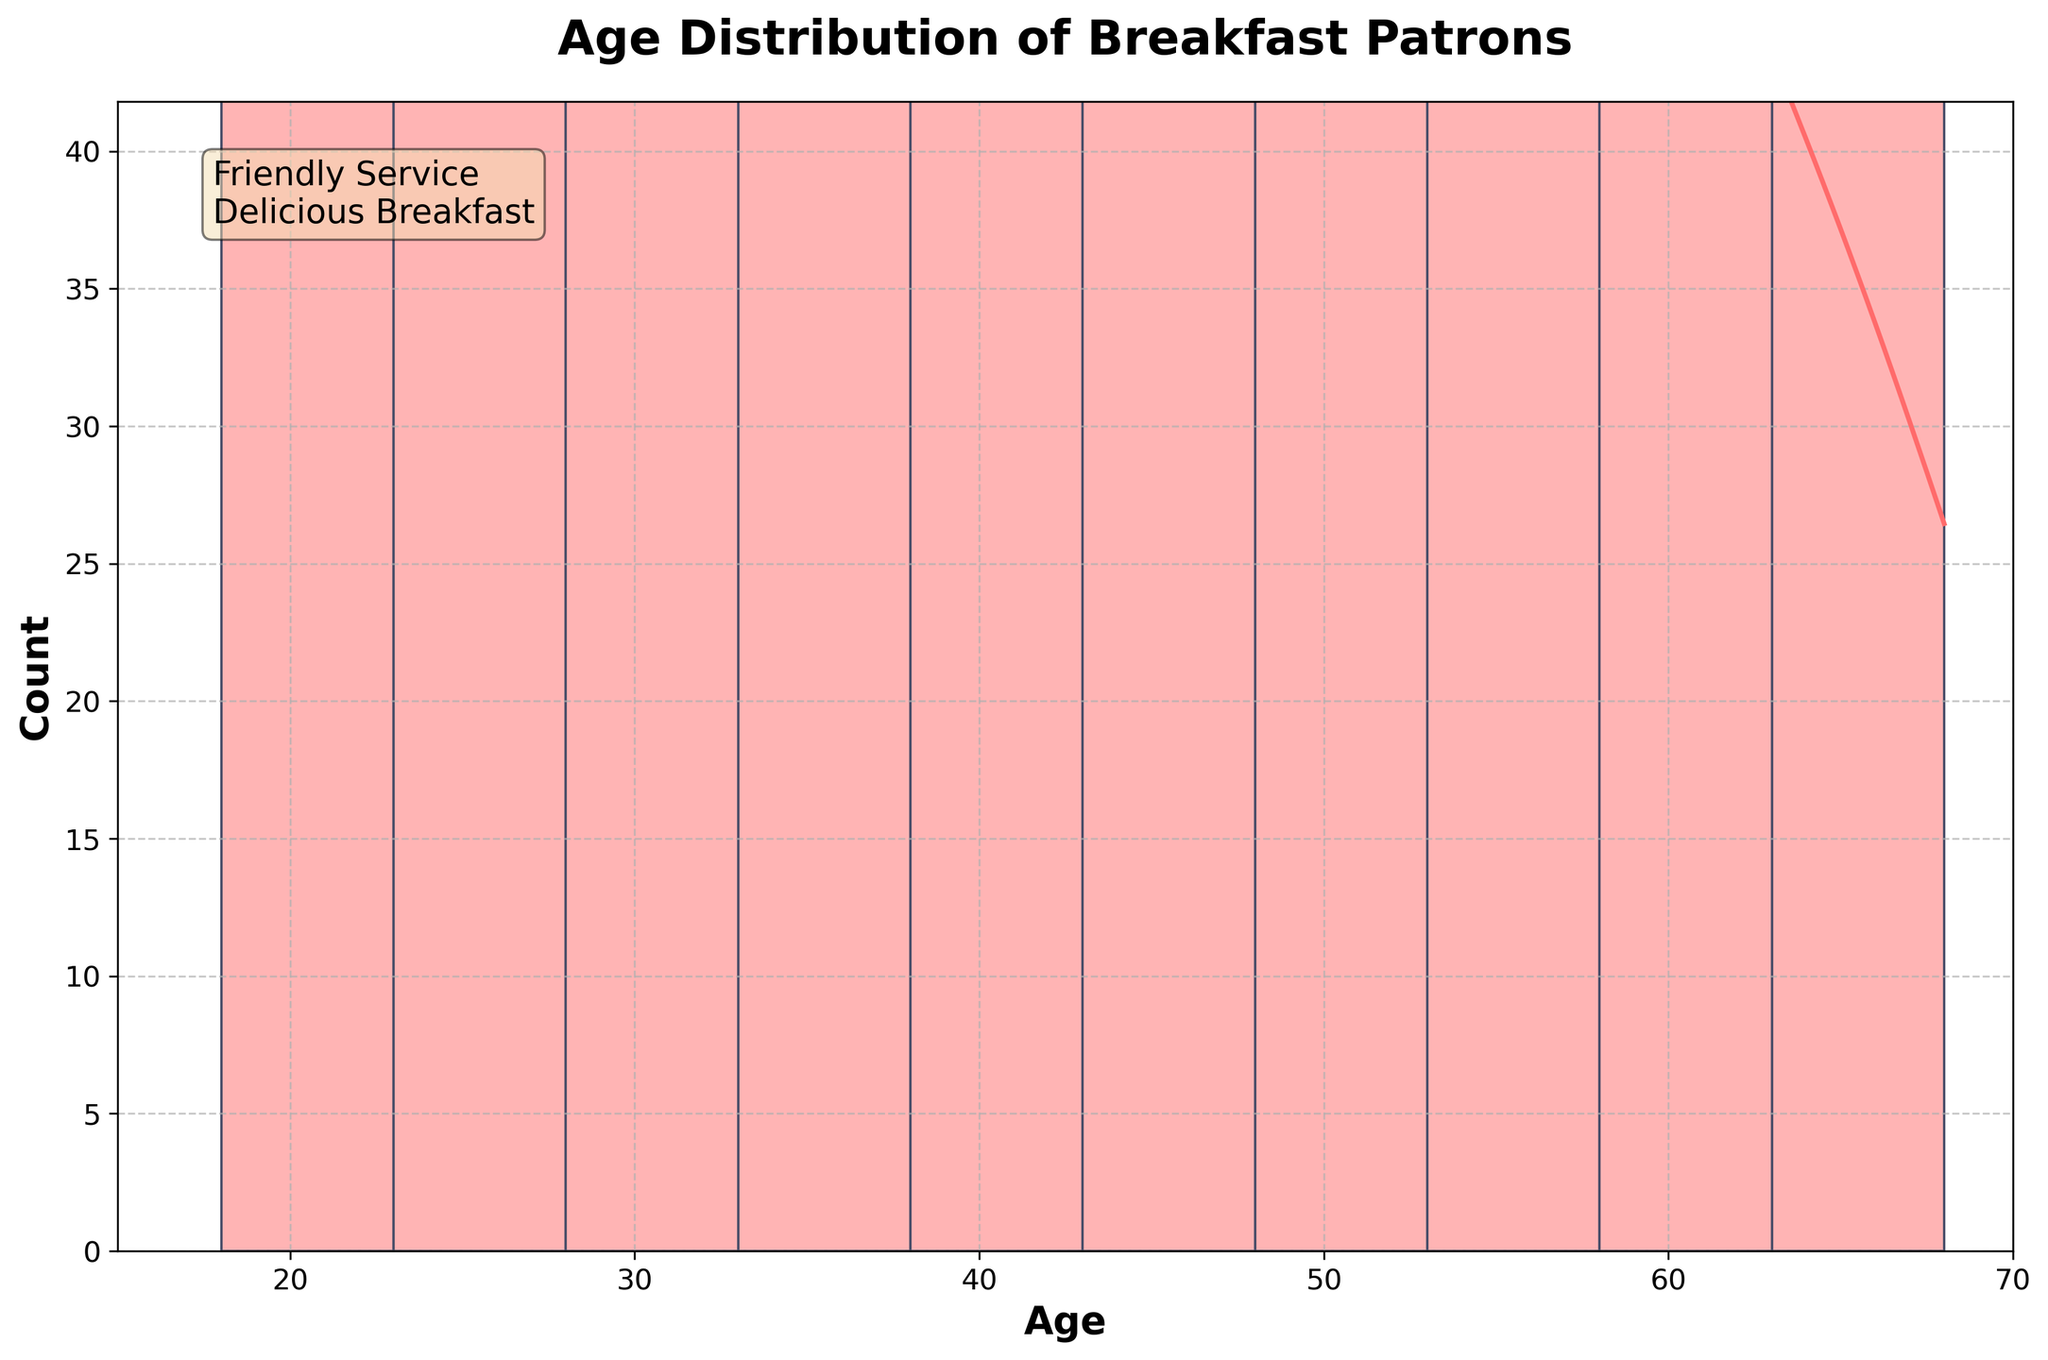what is the title of the figure? The title is usually located at the top center of the figure. It summarizes what the figure is about. In this case, it states, "Age Distribution of Breakfast Patrons."
Answer: Age Distribution of Breakfast Patrons what is the color of the density curve in the figure? The density curve is represented by a line in the figure. It is visually distinct from the bars due to its unique color. In this case, it is a greenish color.
Answer: Greenish How many age groups are there in the histogram? The age groups on the x-axis are distinct bars separated into different age ranges. By counting the distinct separations along the x-axis, we determine the number of age groups.
Answer: 14 what is the age range with the highest count of breakfast patrons? Looking at the bars, we can identify the age range with the highest count by finding the tallest bar on the histogram. It is the age group around 34 years old.
Answer: Around 34 years How does the average count of Tuesday compare to Monday? We calculate the average count by adding up all counts for Tuesday and Monday, then dividing by the number of age groups for each day and compare the two averages.
Answer: Tuesday has a higher average What ages show a notable dip in the density curve? The density curve's notable dips are where the line drops significantly compared to other ages. We identify these dips visually from the line.
Answer: Around 25 and 60 years which day has the widest spread in age distribution? By analyzing the patterns of the histogram bars and the density curve for each day in the histogram, we estimate which day has the longest range in age distribution.
Answer: Saturday what is the general trend in the age of breakfast patrons from Monday to Sunday? By looking at the histogram and density curves for each day and noting how the counts change across the week, we determine if there's an increasing, decreasing, or static trend.
Answer: Increase in middle-aged patrons towards the weekend Which age range appears equally popular every day? We check the age groups where the density (height of bars) and KDE line does not significantly change throughout the days.
Answer: Around 30-35 years 